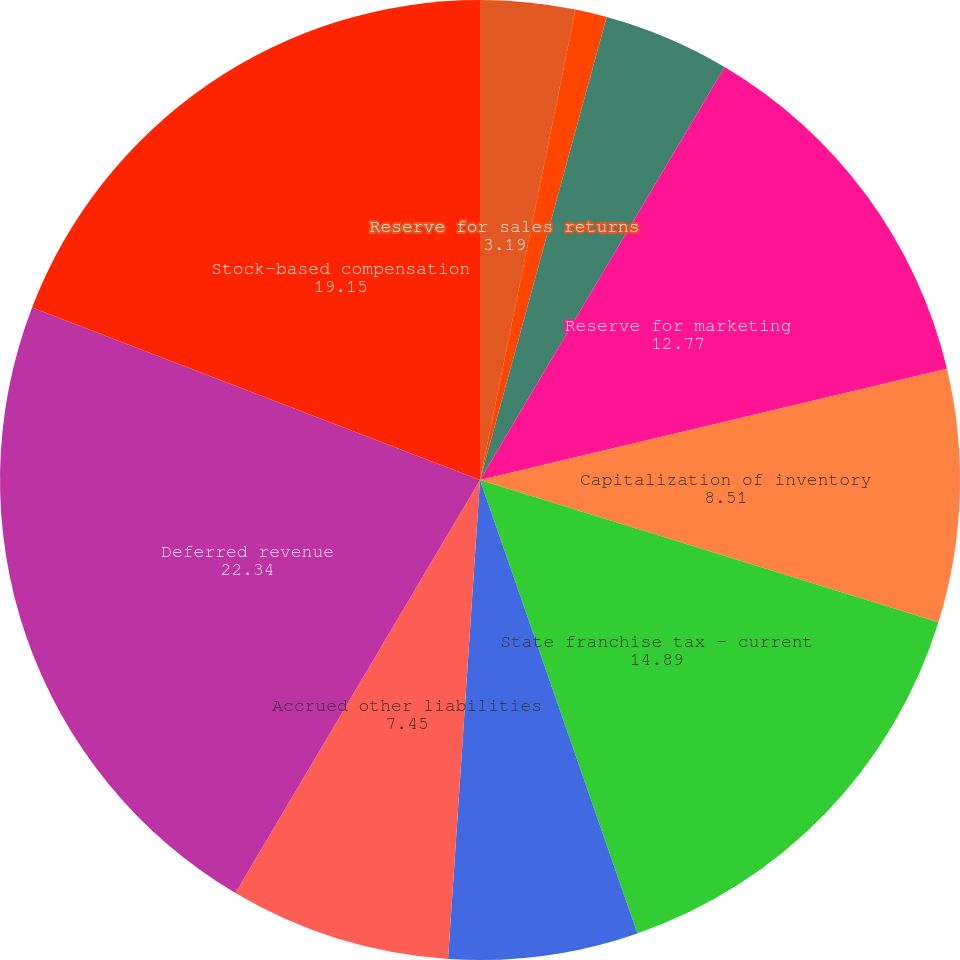Convert chart. <chart><loc_0><loc_0><loc_500><loc_500><pie_chart><fcel>Reserve for sales returns<fcel>Reserve for doubtful accounts<fcel>Reserve for inventory<fcel>Reserve for marketing<fcel>Capitalization of inventory<fcel>State franchise tax - current<fcel>Accrued compensation<fcel>Accrued other liabilities<fcel>Deferred revenue<fcel>Stock-based compensation<nl><fcel>3.19%<fcel>1.06%<fcel>4.26%<fcel>12.77%<fcel>8.51%<fcel>14.89%<fcel>6.38%<fcel>7.45%<fcel>22.34%<fcel>19.15%<nl></chart> 